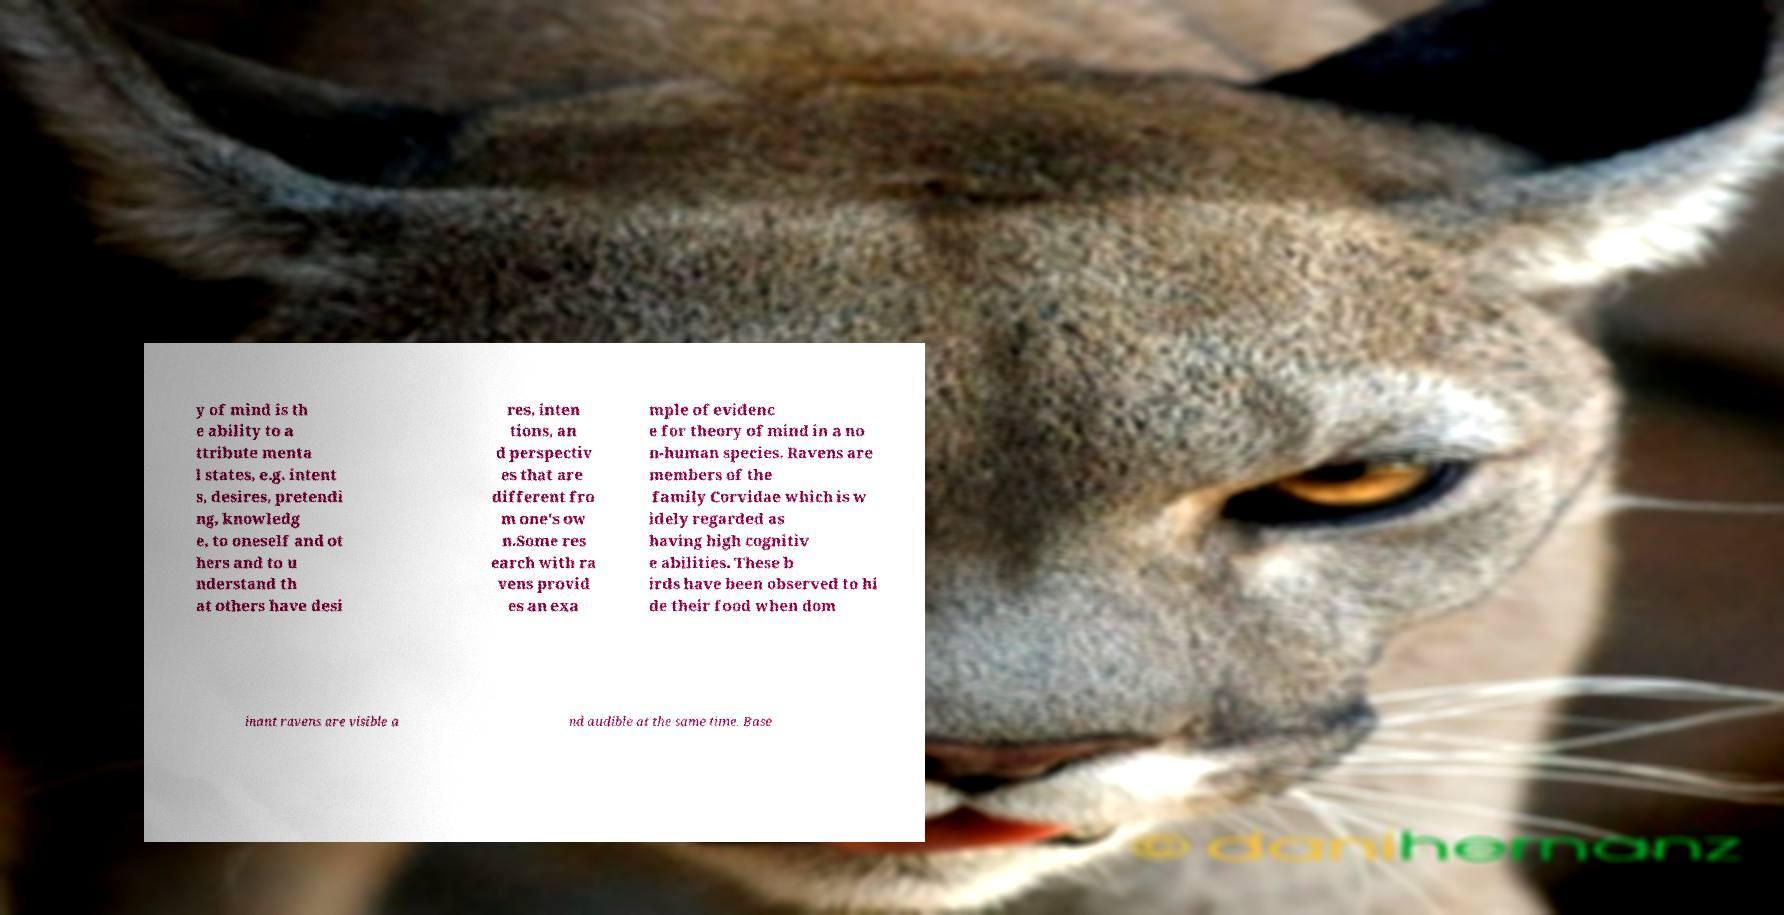What messages or text are displayed in this image? I need them in a readable, typed format. y of mind is th e ability to a ttribute menta l states, e.g. intent s, desires, pretendi ng, knowledg e, to oneself and ot hers and to u nderstand th at others have desi res, inten tions, an d perspectiv es that are different fro m one's ow n.Some res earch with ra vens provid es an exa mple of evidenc e for theory of mind in a no n-human species. Ravens are members of the family Corvidae which is w idely regarded as having high cognitiv e abilities. These b irds have been observed to hi de their food when dom inant ravens are visible a nd audible at the same time. Base 